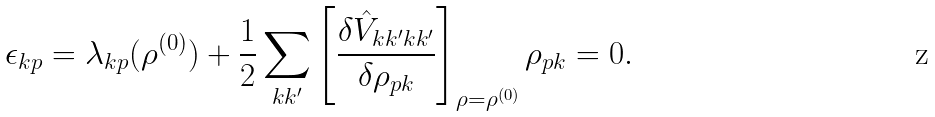Convert formula to latex. <formula><loc_0><loc_0><loc_500><loc_500>\epsilon _ { k p } = \lambda _ { k p } ( \rho ^ { ( 0 ) } ) + \frac { 1 } { 2 } \sum _ { k k ^ { \prime } } \left [ \frac { \delta \hat { V } _ { k k ^ { \prime } k k ^ { \prime } } } { \delta \rho _ { p k } } \right ] _ { \rho = \rho ^ { ( 0 ) } } \rho _ { p k } = 0 .</formula> 